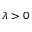Convert formula to latex. <formula><loc_0><loc_0><loc_500><loc_500>\lambda > 0</formula> 